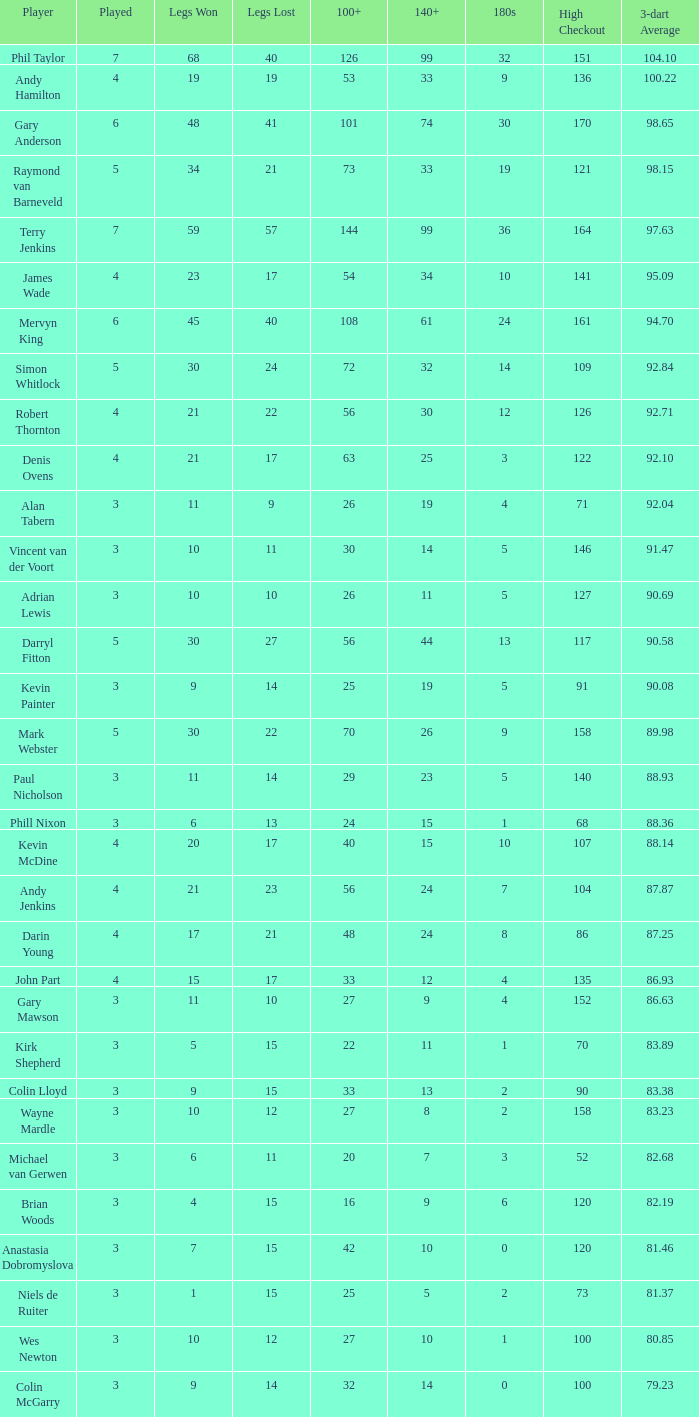What is the total number of 3-dart average when legs lost is larger than 41, and played is larger than 7? 0.0. 